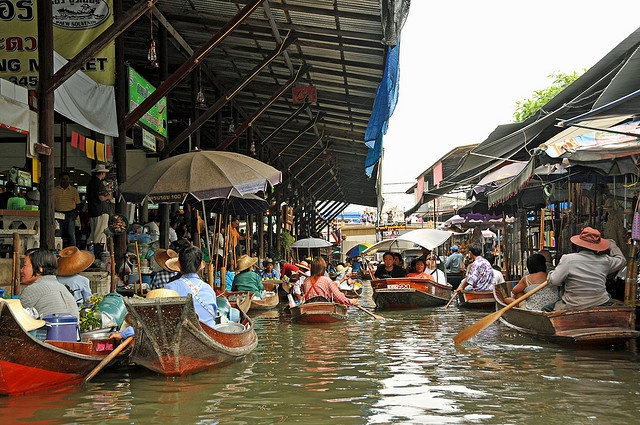Describe the objects in this image and their specific colors. I can see people in black, maroon, and gray tones, boat in black, gray, and maroon tones, umbrella in black and gray tones, boat in black, maroon, and brown tones, and boat in black, brown, and maroon tones in this image. 